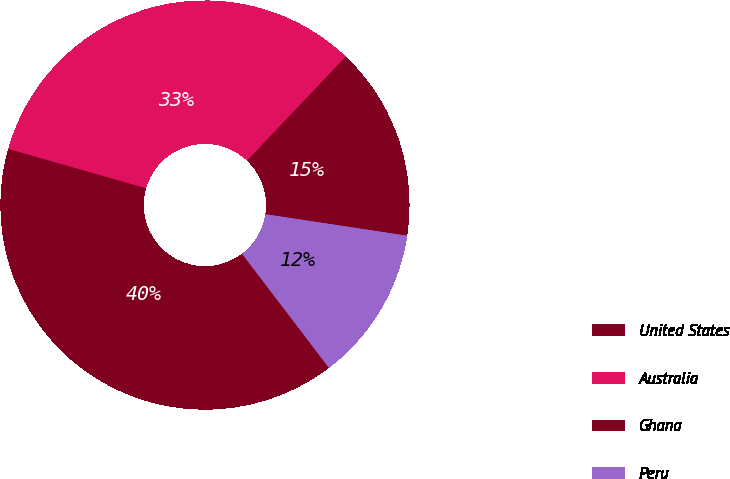Convert chart. <chart><loc_0><loc_0><loc_500><loc_500><pie_chart><fcel>United States<fcel>Australia<fcel>Ghana<fcel>Peru<nl><fcel>39.8%<fcel>32.65%<fcel>15.31%<fcel>12.24%<nl></chart> 